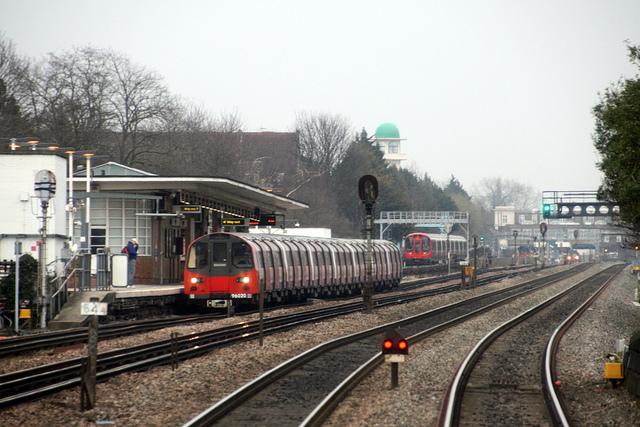How many lights are on?
Quick response, please. 4. Is this a passenger train?
Short answer required. Yes. Are the weather conditions sunny or overcast?
Answer briefly. Overcast. 